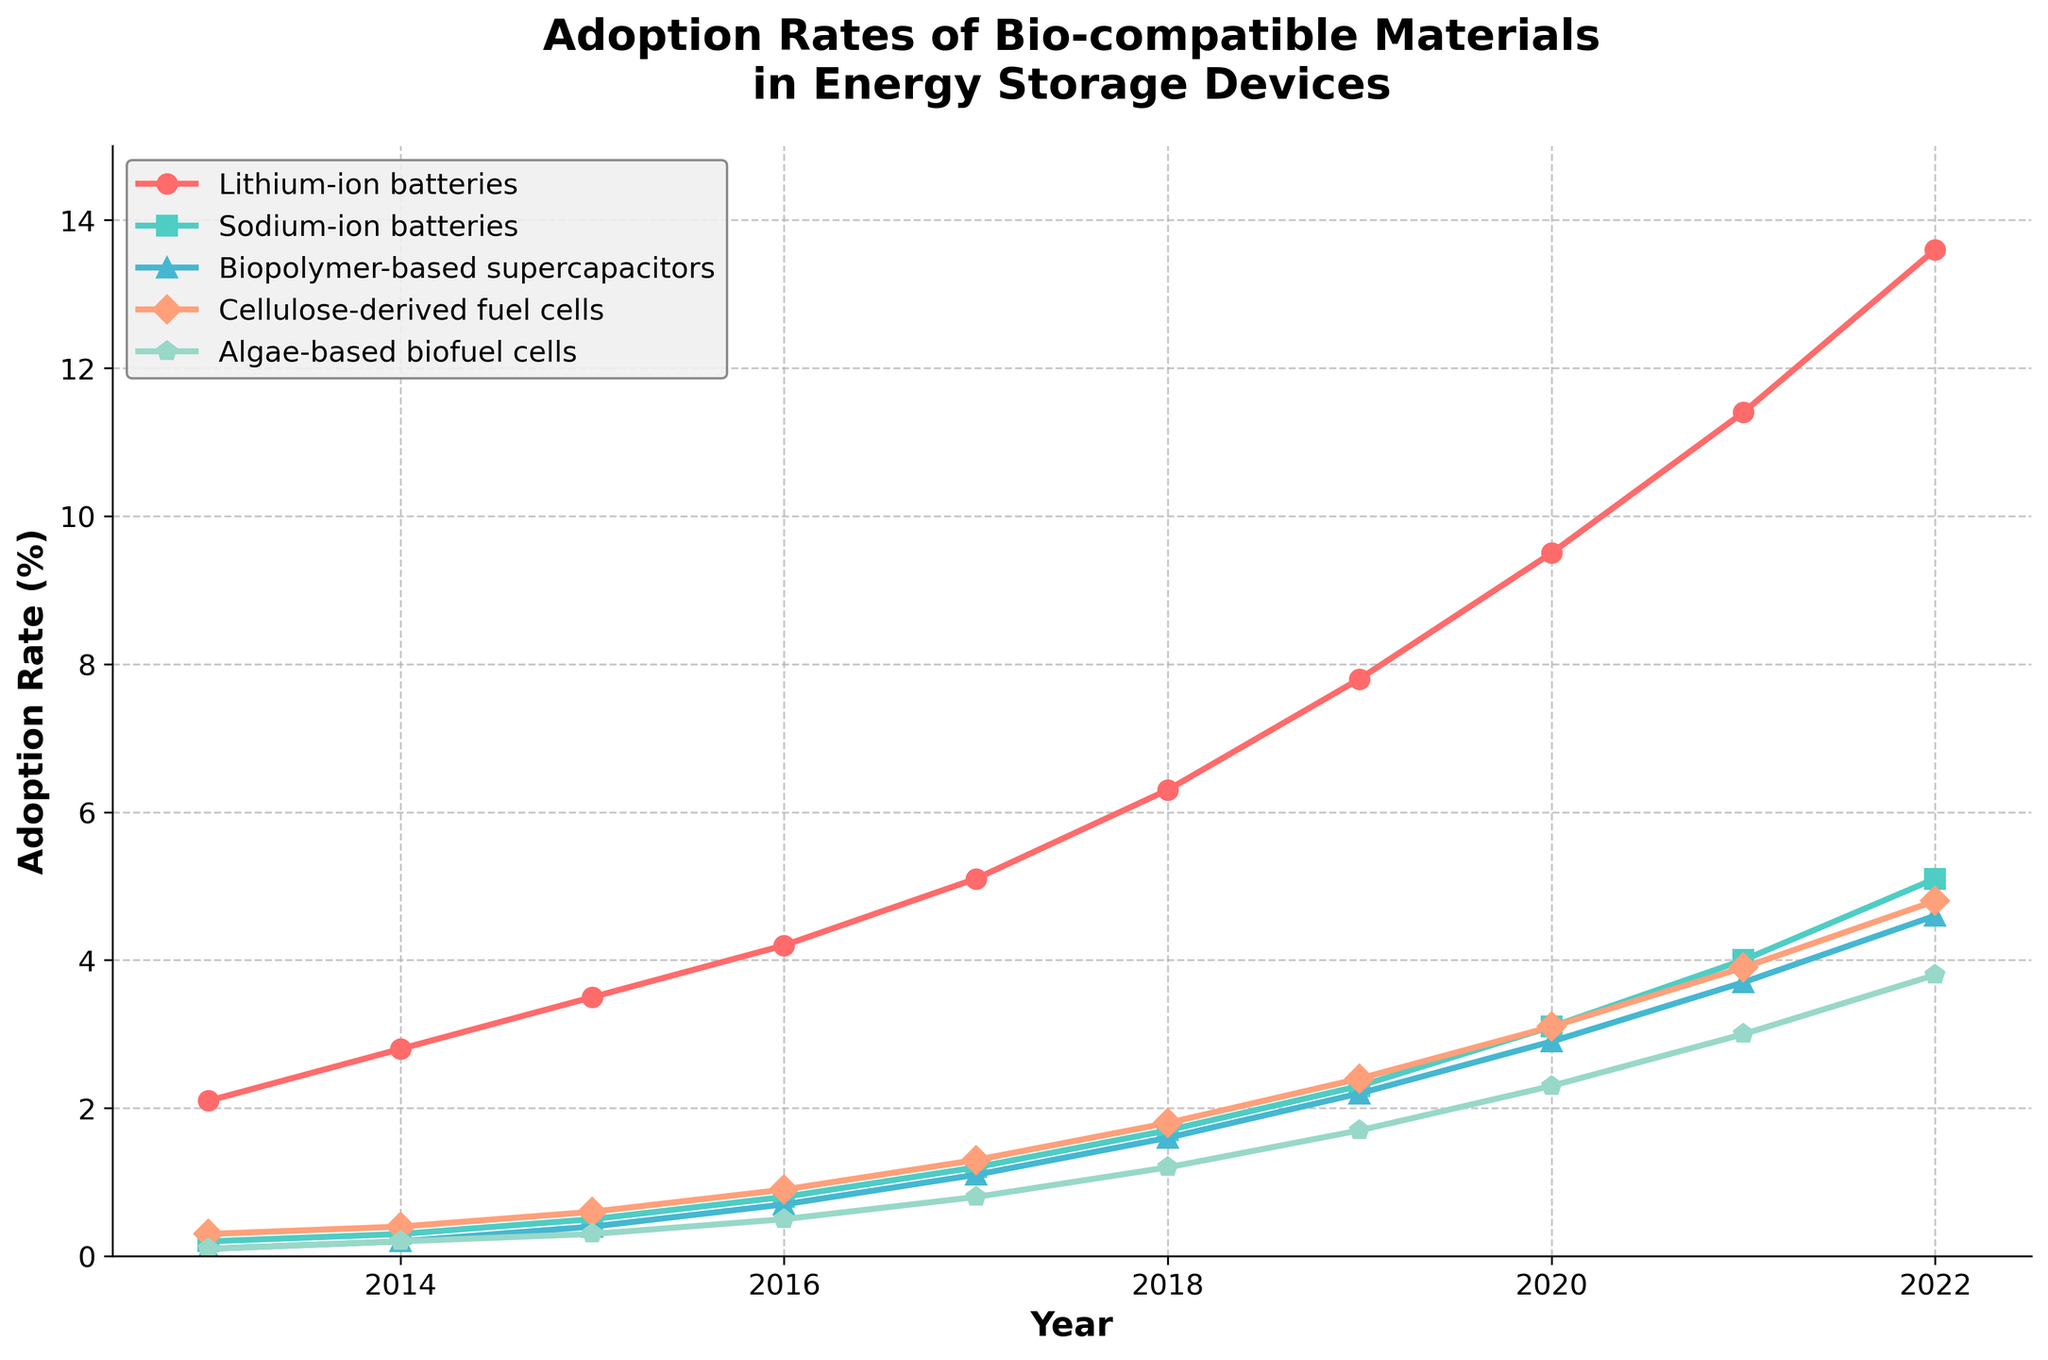Which energy storage device showed the highest adoption rate in 2022? Look at the chart for 2022 and find the line that ends at the highest point. This line corresponds to the energy storage device with the highest adoption rate.
Answer: Lithium-ion batteries What is the total adoption rate of Biopolymer-based supercapacitors over the decade? Sum the adoption rates of Biopolymer-based supercapacitors for each year from 2013 to 2022: 0.1 + 0.2 + 0.4 + 0.7 + 1.1 + 1.6 + 2.2 + 2.9 + 3.7 + 4.6.
Answer: 17.5 By how many percentage points did the adoption rate of Sodium-ion batteries increase from 2013 to 2022? Subtract the adoption rate of Sodium-ion batteries in 2013 from that in 2022: 5.1 - 0.2.
Answer: 4.9 percentage points Which energy storage device had a higher adoption rate in 2018: Algae-based biofuel cells or Cellulose-derived fuel cells? Compare the adoption rates of Algae-based biofuel cells and Cellulose-derived fuel cells in 2018 by looking at their corresponding points on the chart.
Answer: Cellulose-derived fuel cells What is the average annual adoption rate of Algae-based biofuel cells from 2013 to 2022? Sum the annual adoption rates of Algae-based biofuel cells over the decade: 0.1 + 0.2 + 0.3 + 0.5 + 0.8 + 1.2 + 1.7 + 2.3 + 3.0 + 3.8. Then, divide by 10 (the number of years).
Answer: 1.39 Which year saw the largest increase in adoption rate for Lithium-ion batteries? Calculate the year-over-year increase in adoption rate for Lithium-ion batteries and find the year with the largest increase: (2014-2013), (2015-2014), ..., (2022-2021).
Answer: 2022 What is the difference in adoption rates between Biopolymer-based supercapacitors and Sodium-ion batteries in 2020? Subtract the adoption rate of Sodium-ion batteries from that of Biopolymer-based supercapacitors in 2020: 2.9 - 3.1.
Answer: -0.2 Which energy storage device's adoption rate grew the fastest between 2015 and 2020? Find the difference in adoption rates from 2015 to 2020 for each energy storage device, then compare to determine which one had the greatest increase.
Answer: Lithium-ion batteries 